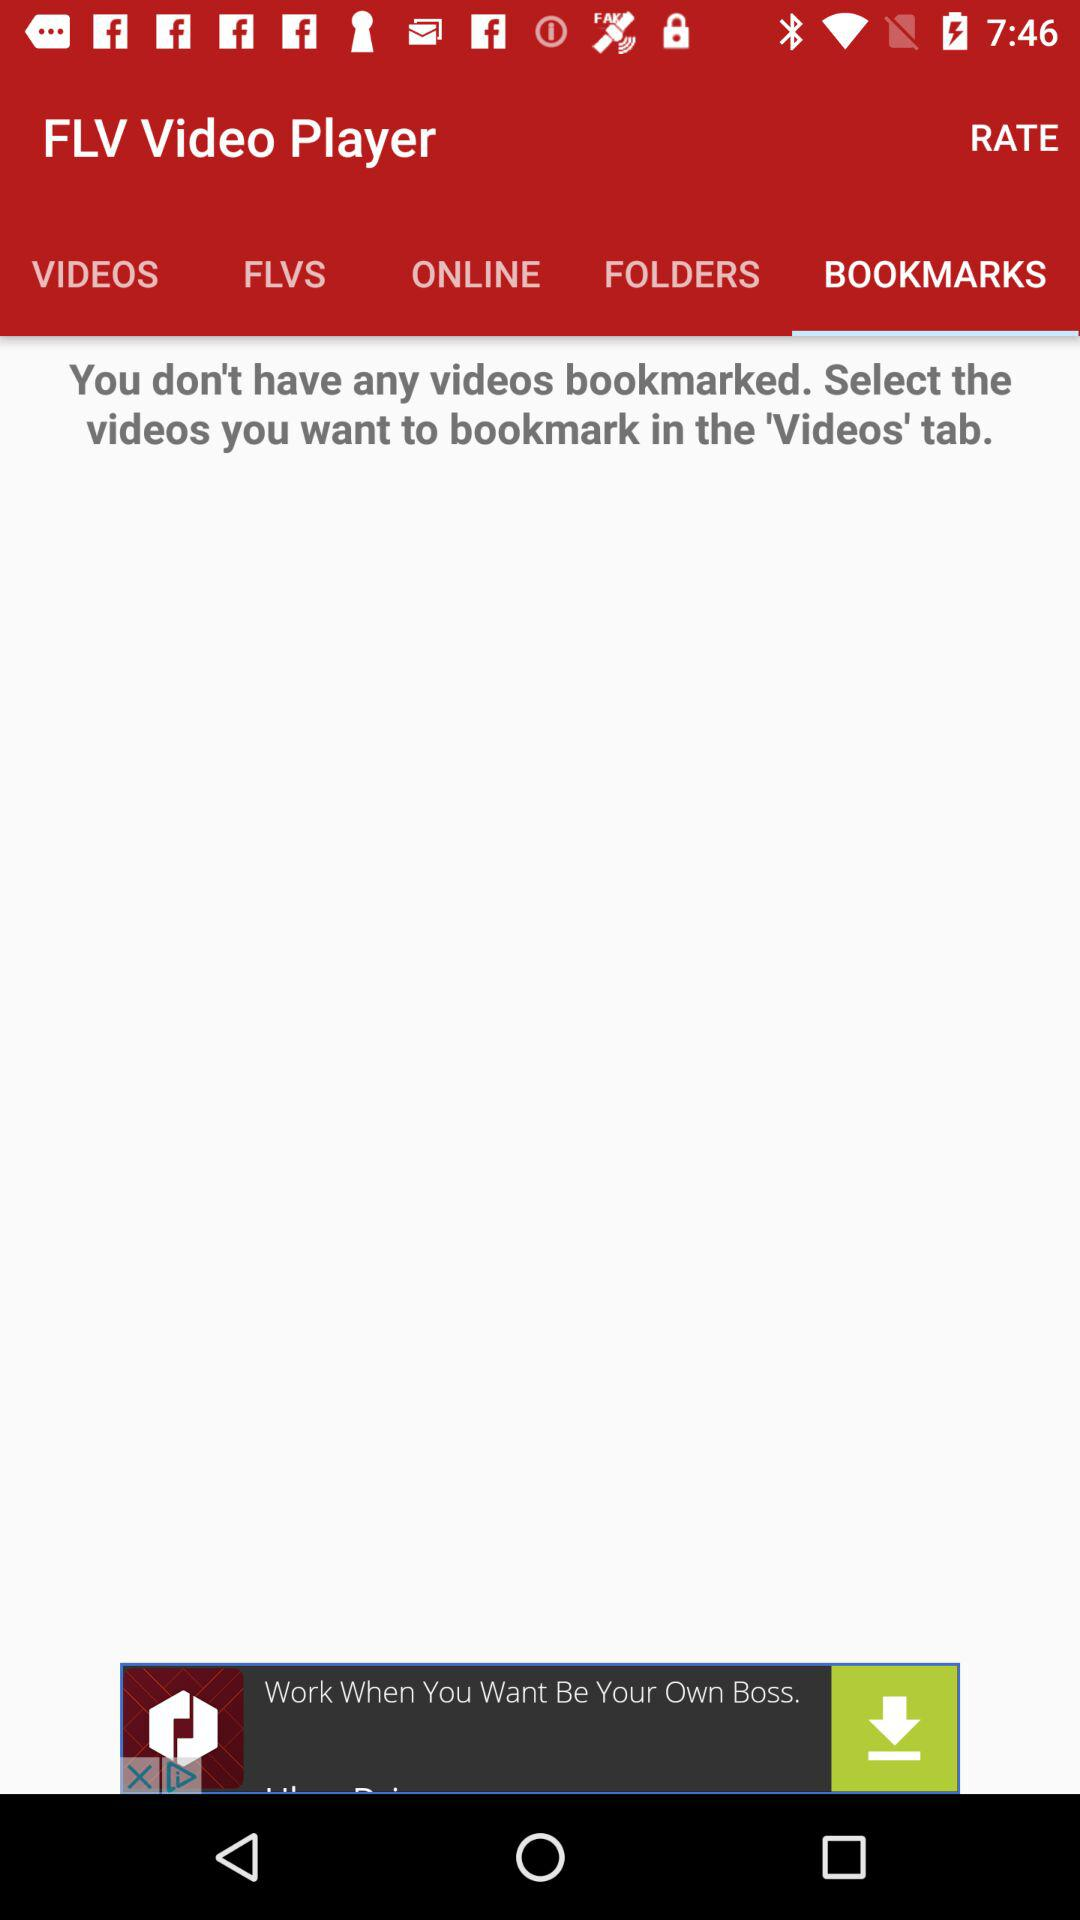What is the selected option in the "FLV Video Player"? The selected option is "BOOKMARKS". 